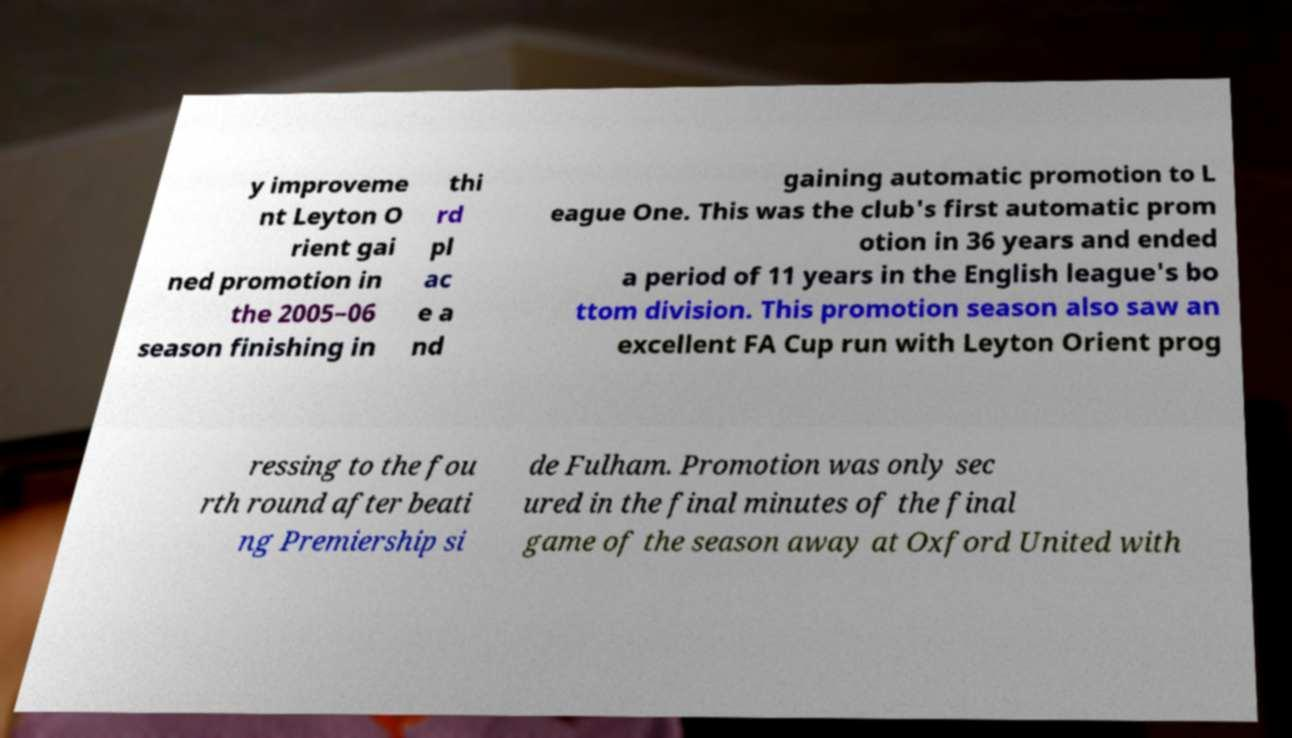I need the written content from this picture converted into text. Can you do that? y improveme nt Leyton O rient gai ned promotion in the 2005–06 season finishing in thi rd pl ac e a nd gaining automatic promotion to L eague One. This was the club's first automatic prom otion in 36 years and ended a period of 11 years in the English league's bo ttom division. This promotion season also saw an excellent FA Cup run with Leyton Orient prog ressing to the fou rth round after beati ng Premiership si de Fulham. Promotion was only sec ured in the final minutes of the final game of the season away at Oxford United with 